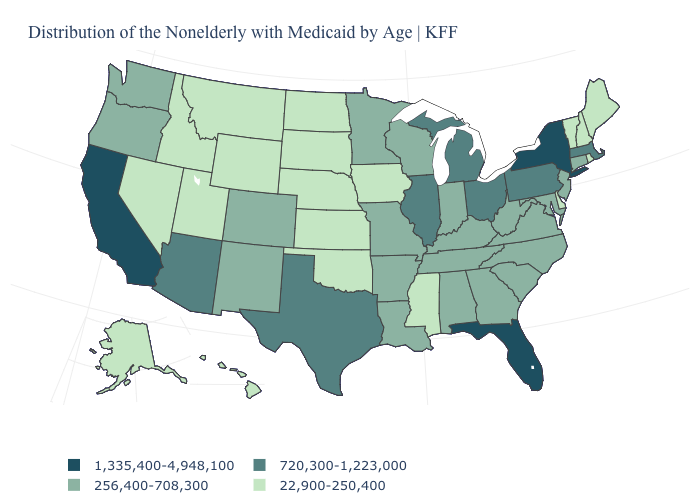Name the states that have a value in the range 256,400-708,300?
Write a very short answer. Alabama, Arkansas, Colorado, Connecticut, Georgia, Indiana, Kentucky, Louisiana, Maryland, Minnesota, Missouri, New Jersey, New Mexico, North Carolina, Oregon, South Carolina, Tennessee, Virginia, Washington, West Virginia, Wisconsin. What is the value of New Jersey?
Answer briefly. 256,400-708,300. Name the states that have a value in the range 256,400-708,300?
Be succinct. Alabama, Arkansas, Colorado, Connecticut, Georgia, Indiana, Kentucky, Louisiana, Maryland, Minnesota, Missouri, New Jersey, New Mexico, North Carolina, Oregon, South Carolina, Tennessee, Virginia, Washington, West Virginia, Wisconsin. What is the value of Virginia?
Concise answer only. 256,400-708,300. How many symbols are there in the legend?
Concise answer only. 4. What is the value of Utah?
Keep it brief. 22,900-250,400. Name the states that have a value in the range 22,900-250,400?
Answer briefly. Alaska, Delaware, Hawaii, Idaho, Iowa, Kansas, Maine, Mississippi, Montana, Nebraska, Nevada, New Hampshire, North Dakota, Oklahoma, Rhode Island, South Dakota, Utah, Vermont, Wyoming. What is the value of Vermont?
Keep it brief. 22,900-250,400. Name the states that have a value in the range 1,335,400-4,948,100?
Write a very short answer. California, Florida, New York. Name the states that have a value in the range 720,300-1,223,000?
Be succinct. Arizona, Illinois, Massachusetts, Michigan, Ohio, Pennsylvania, Texas. What is the highest value in states that border Utah?
Be succinct. 720,300-1,223,000. Name the states that have a value in the range 22,900-250,400?
Quick response, please. Alaska, Delaware, Hawaii, Idaho, Iowa, Kansas, Maine, Mississippi, Montana, Nebraska, Nevada, New Hampshire, North Dakota, Oklahoma, Rhode Island, South Dakota, Utah, Vermont, Wyoming. Does Montana have the lowest value in the West?
Give a very brief answer. Yes. What is the highest value in the USA?
Concise answer only. 1,335,400-4,948,100. Does Nebraska have a higher value than Arkansas?
Give a very brief answer. No. 